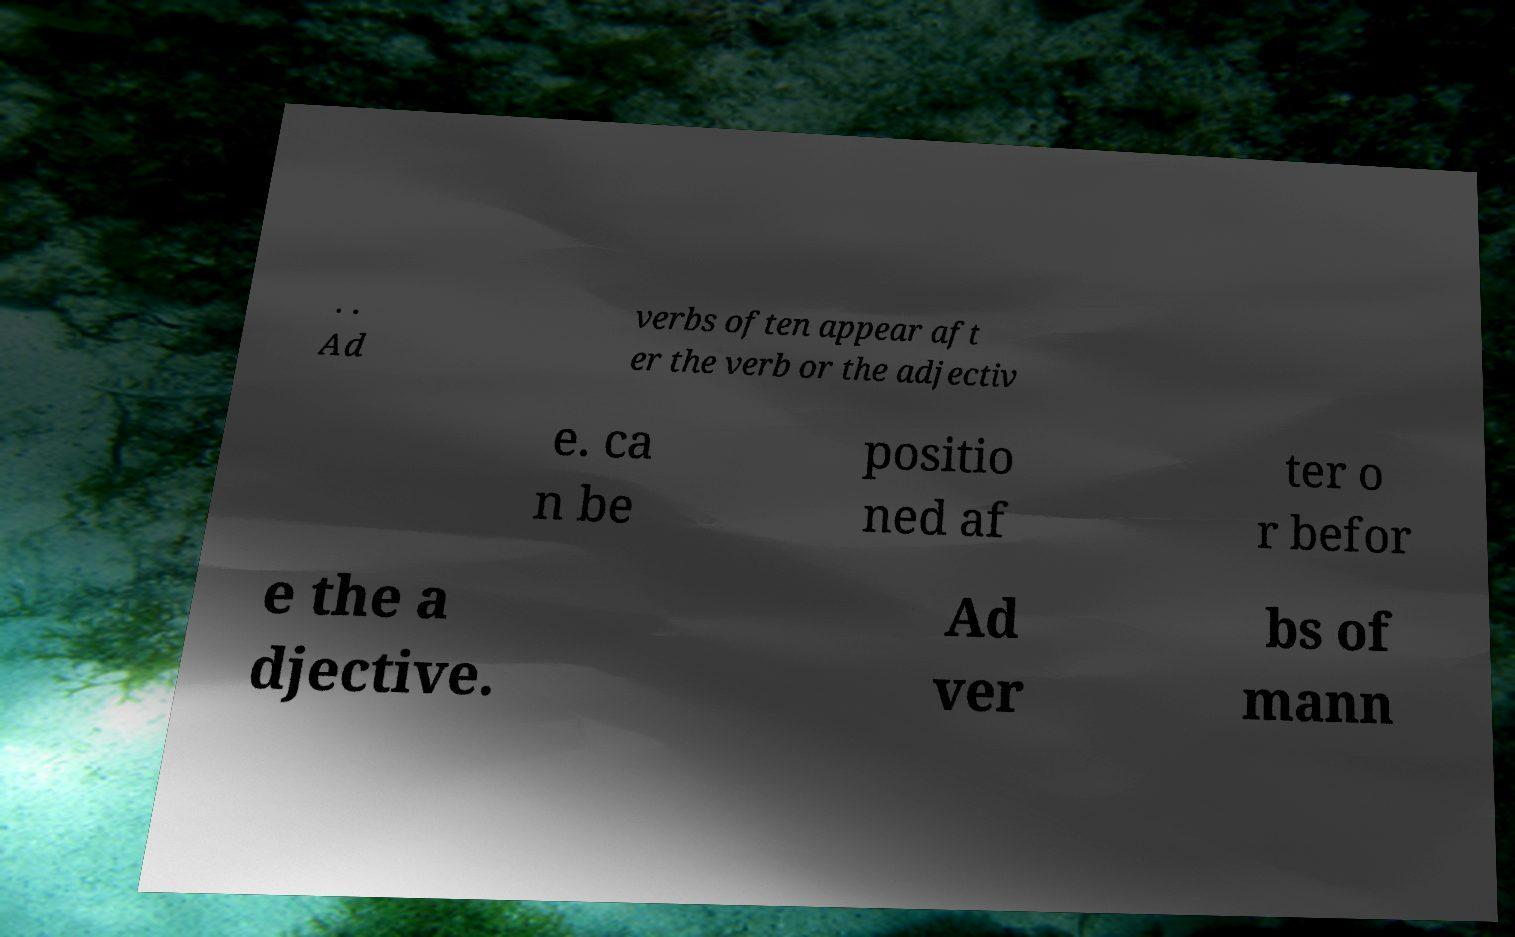Can you read and provide the text displayed in the image?This photo seems to have some interesting text. Can you extract and type it out for me? . . Ad verbs often appear aft er the verb or the adjectiv e. ca n be positio ned af ter o r befor e the a djective. Ad ver bs of mann 